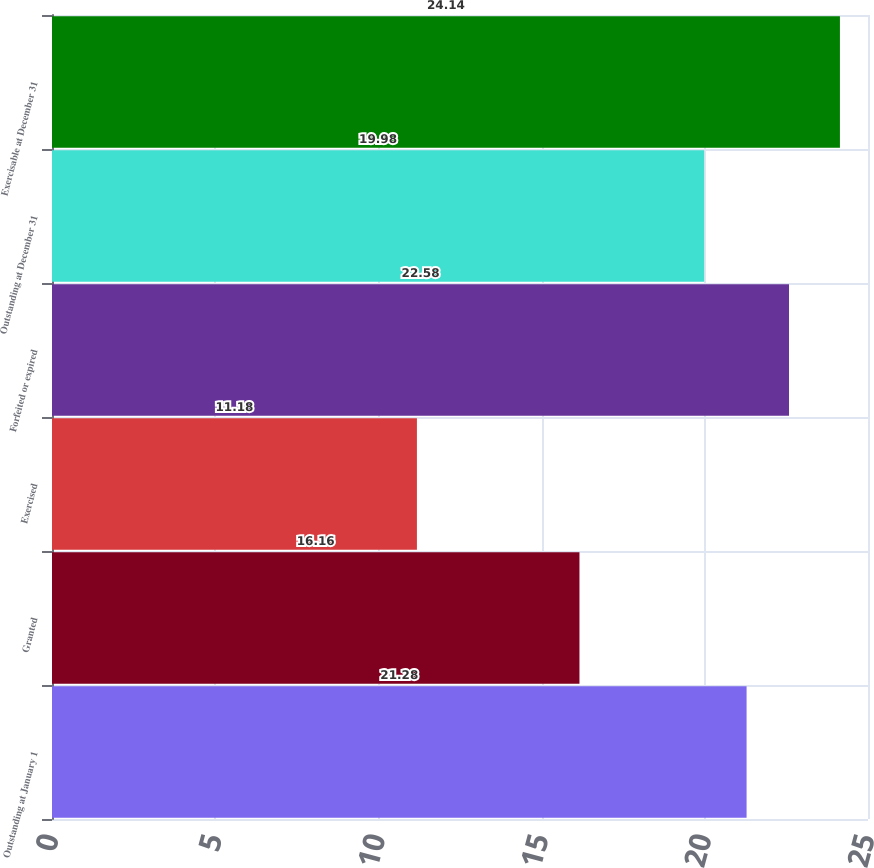Convert chart to OTSL. <chart><loc_0><loc_0><loc_500><loc_500><bar_chart><fcel>Outstanding at January 1<fcel>Granted<fcel>Exercised<fcel>Forfeited or expired<fcel>Outstanding at December 31<fcel>Exercisable at December 31<nl><fcel>21.28<fcel>16.16<fcel>11.18<fcel>22.58<fcel>19.98<fcel>24.14<nl></chart> 